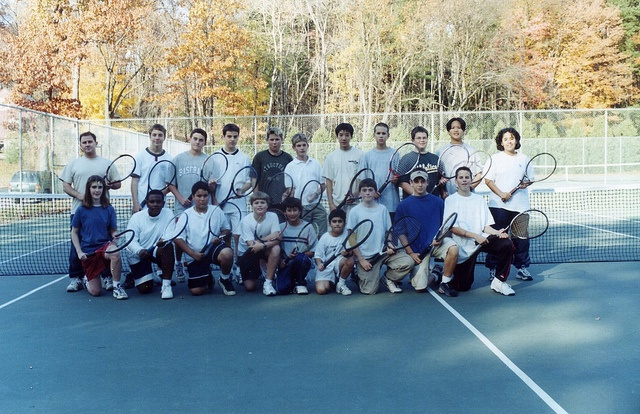Describe the objects in this image and their specific colors. I can see people in lightgray, black, navy, and lightblue tones, people in lightgray, navy, black, gray, and darkgray tones, people in lightgray, gray, lightblue, and black tones, people in lightgray, black, gray, and lightblue tones, and people in lightgray, black, navy, and gray tones in this image. 